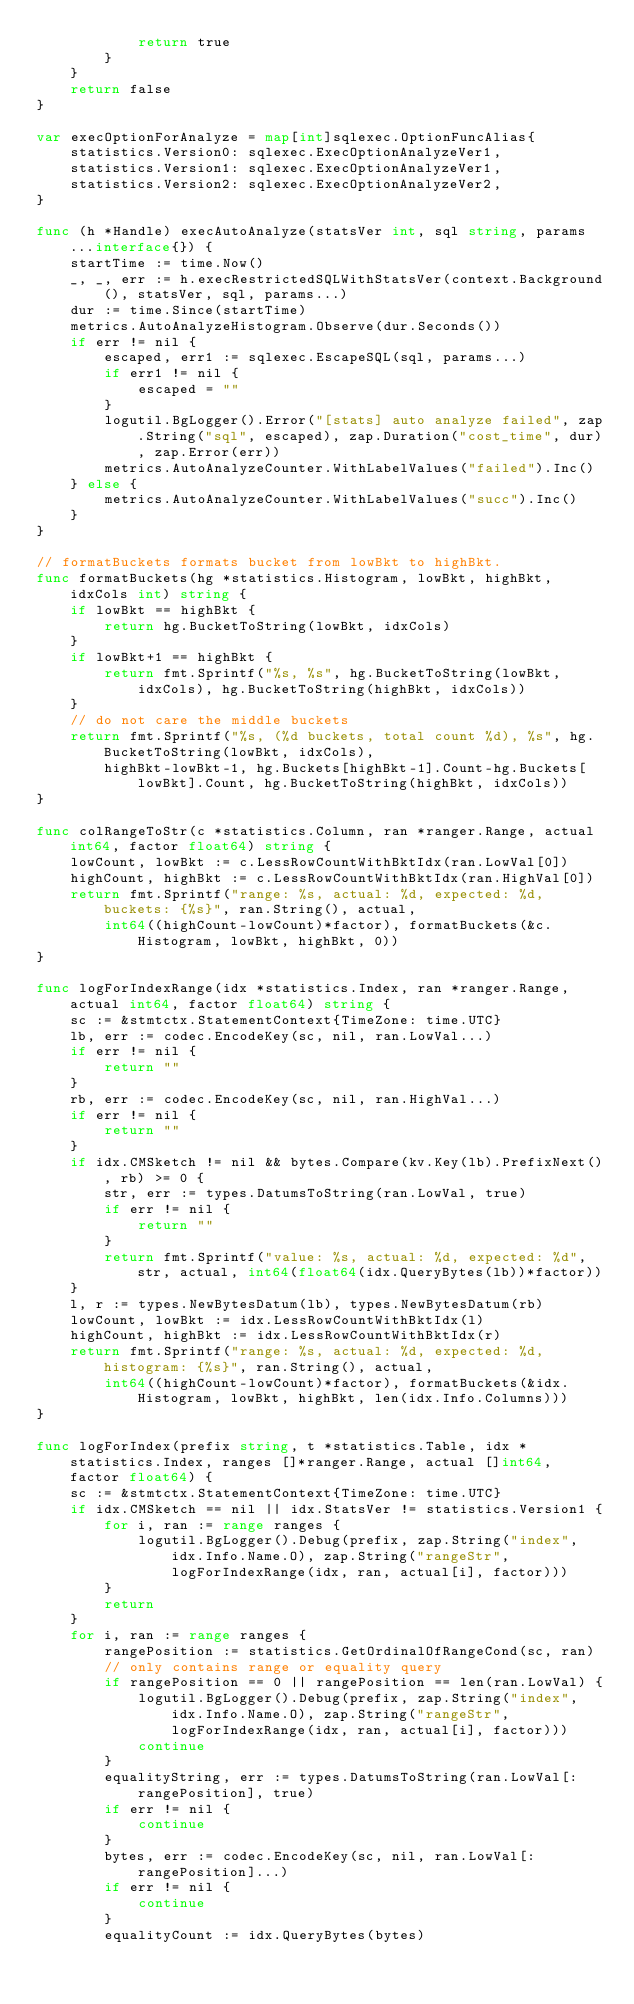<code> <loc_0><loc_0><loc_500><loc_500><_Go_>			return true
		}
	}
	return false
}

var execOptionForAnalyze = map[int]sqlexec.OptionFuncAlias{
	statistics.Version0: sqlexec.ExecOptionAnalyzeVer1,
	statistics.Version1: sqlexec.ExecOptionAnalyzeVer1,
	statistics.Version2: sqlexec.ExecOptionAnalyzeVer2,
}

func (h *Handle) execAutoAnalyze(statsVer int, sql string, params ...interface{}) {
	startTime := time.Now()
	_, _, err := h.execRestrictedSQLWithStatsVer(context.Background(), statsVer, sql, params...)
	dur := time.Since(startTime)
	metrics.AutoAnalyzeHistogram.Observe(dur.Seconds())
	if err != nil {
		escaped, err1 := sqlexec.EscapeSQL(sql, params...)
		if err1 != nil {
			escaped = ""
		}
		logutil.BgLogger().Error("[stats] auto analyze failed", zap.String("sql", escaped), zap.Duration("cost_time", dur), zap.Error(err))
		metrics.AutoAnalyzeCounter.WithLabelValues("failed").Inc()
	} else {
		metrics.AutoAnalyzeCounter.WithLabelValues("succ").Inc()
	}
}

// formatBuckets formats bucket from lowBkt to highBkt.
func formatBuckets(hg *statistics.Histogram, lowBkt, highBkt, idxCols int) string {
	if lowBkt == highBkt {
		return hg.BucketToString(lowBkt, idxCols)
	}
	if lowBkt+1 == highBkt {
		return fmt.Sprintf("%s, %s", hg.BucketToString(lowBkt, idxCols), hg.BucketToString(highBkt, idxCols))
	}
	// do not care the middle buckets
	return fmt.Sprintf("%s, (%d buckets, total count %d), %s", hg.BucketToString(lowBkt, idxCols),
		highBkt-lowBkt-1, hg.Buckets[highBkt-1].Count-hg.Buckets[lowBkt].Count, hg.BucketToString(highBkt, idxCols))
}

func colRangeToStr(c *statistics.Column, ran *ranger.Range, actual int64, factor float64) string {
	lowCount, lowBkt := c.LessRowCountWithBktIdx(ran.LowVal[0])
	highCount, highBkt := c.LessRowCountWithBktIdx(ran.HighVal[0])
	return fmt.Sprintf("range: %s, actual: %d, expected: %d, buckets: {%s}", ran.String(), actual,
		int64((highCount-lowCount)*factor), formatBuckets(&c.Histogram, lowBkt, highBkt, 0))
}

func logForIndexRange(idx *statistics.Index, ran *ranger.Range, actual int64, factor float64) string {
	sc := &stmtctx.StatementContext{TimeZone: time.UTC}
	lb, err := codec.EncodeKey(sc, nil, ran.LowVal...)
	if err != nil {
		return ""
	}
	rb, err := codec.EncodeKey(sc, nil, ran.HighVal...)
	if err != nil {
		return ""
	}
	if idx.CMSketch != nil && bytes.Compare(kv.Key(lb).PrefixNext(), rb) >= 0 {
		str, err := types.DatumsToString(ran.LowVal, true)
		if err != nil {
			return ""
		}
		return fmt.Sprintf("value: %s, actual: %d, expected: %d", str, actual, int64(float64(idx.QueryBytes(lb))*factor))
	}
	l, r := types.NewBytesDatum(lb), types.NewBytesDatum(rb)
	lowCount, lowBkt := idx.LessRowCountWithBktIdx(l)
	highCount, highBkt := idx.LessRowCountWithBktIdx(r)
	return fmt.Sprintf("range: %s, actual: %d, expected: %d, histogram: {%s}", ran.String(), actual,
		int64((highCount-lowCount)*factor), formatBuckets(&idx.Histogram, lowBkt, highBkt, len(idx.Info.Columns)))
}

func logForIndex(prefix string, t *statistics.Table, idx *statistics.Index, ranges []*ranger.Range, actual []int64, factor float64) {
	sc := &stmtctx.StatementContext{TimeZone: time.UTC}
	if idx.CMSketch == nil || idx.StatsVer != statistics.Version1 {
		for i, ran := range ranges {
			logutil.BgLogger().Debug(prefix, zap.String("index", idx.Info.Name.O), zap.String("rangeStr", logForIndexRange(idx, ran, actual[i], factor)))
		}
		return
	}
	for i, ran := range ranges {
		rangePosition := statistics.GetOrdinalOfRangeCond(sc, ran)
		// only contains range or equality query
		if rangePosition == 0 || rangePosition == len(ran.LowVal) {
			logutil.BgLogger().Debug(prefix, zap.String("index", idx.Info.Name.O), zap.String("rangeStr", logForIndexRange(idx, ran, actual[i], factor)))
			continue
		}
		equalityString, err := types.DatumsToString(ran.LowVal[:rangePosition], true)
		if err != nil {
			continue
		}
		bytes, err := codec.EncodeKey(sc, nil, ran.LowVal[:rangePosition]...)
		if err != nil {
			continue
		}
		equalityCount := idx.QueryBytes(bytes)</code> 